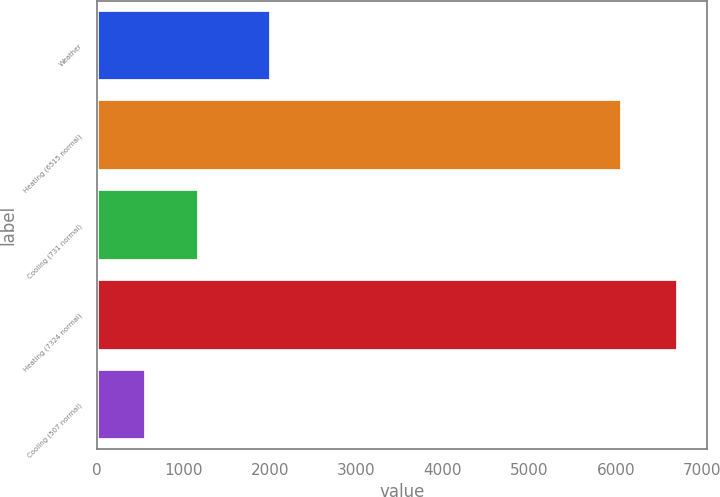<chart> <loc_0><loc_0><loc_500><loc_500><bar_chart><fcel>Weather<fcel>Heating (6515 normal)<fcel>Cooling (731 normal)<fcel>Heating (7324 normal)<fcel>Cooling (507 normal)<nl><fcel>2016<fcel>6068<fcel>1186.3<fcel>6715<fcel>572<nl></chart> 